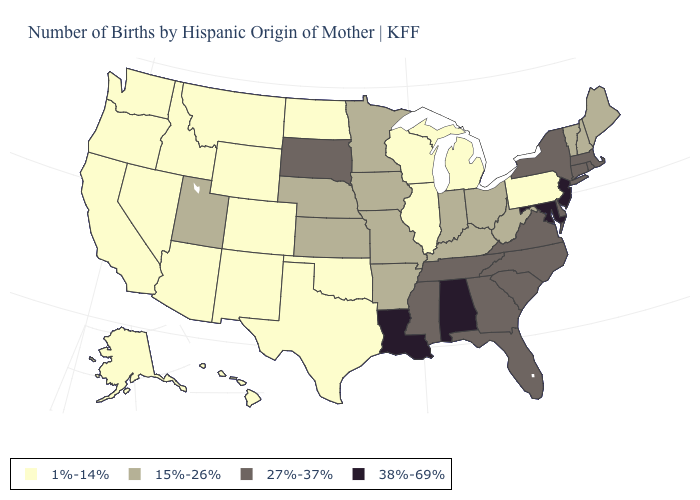Does Michigan have the lowest value in the MidWest?
Give a very brief answer. Yes. What is the value of Vermont?
Keep it brief. 15%-26%. What is the value of North Carolina?
Keep it brief. 27%-37%. What is the lowest value in the MidWest?
Keep it brief. 1%-14%. Does California have a lower value than Rhode Island?
Short answer required. Yes. What is the highest value in the South ?
Quick response, please. 38%-69%. Name the states that have a value in the range 38%-69%?
Write a very short answer. Alabama, Louisiana, Maryland, New Jersey. Does the map have missing data?
Give a very brief answer. No. Does Maryland have the highest value in the USA?
Answer briefly. Yes. Does Maryland have the same value as Alabama?
Give a very brief answer. Yes. Among the states that border North Dakota , does Montana have the lowest value?
Be succinct. Yes. Name the states that have a value in the range 1%-14%?
Short answer required. Alaska, Arizona, California, Colorado, Hawaii, Idaho, Illinois, Michigan, Montana, Nevada, New Mexico, North Dakota, Oklahoma, Oregon, Pennsylvania, Texas, Washington, Wisconsin, Wyoming. Does Virginia have a higher value than Georgia?
Answer briefly. No. Does the first symbol in the legend represent the smallest category?
Give a very brief answer. Yes. Name the states that have a value in the range 1%-14%?
Write a very short answer. Alaska, Arizona, California, Colorado, Hawaii, Idaho, Illinois, Michigan, Montana, Nevada, New Mexico, North Dakota, Oklahoma, Oregon, Pennsylvania, Texas, Washington, Wisconsin, Wyoming. 